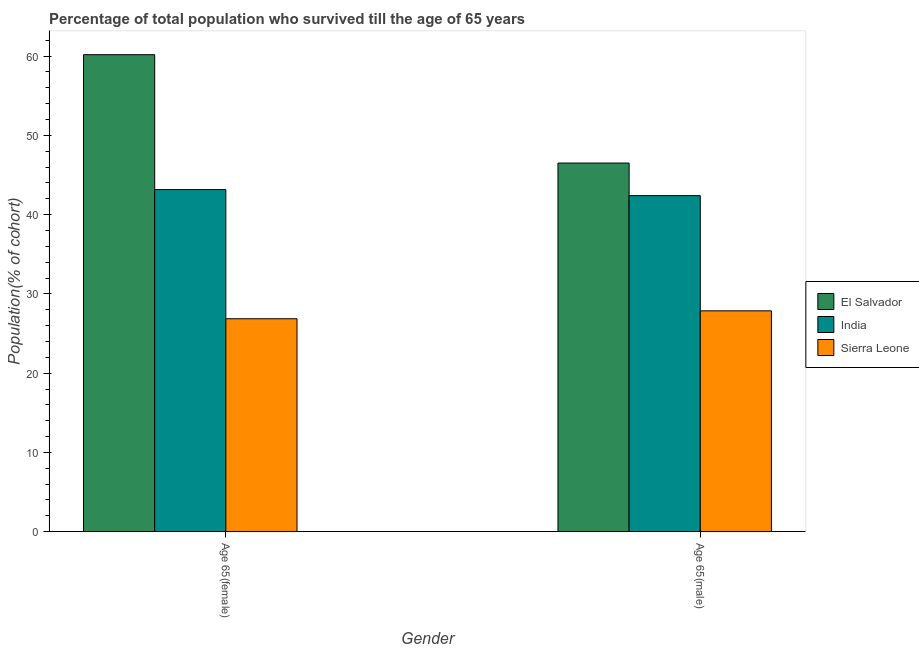Are the number of bars per tick equal to the number of legend labels?
Keep it short and to the point. Yes. How many bars are there on the 2nd tick from the right?
Keep it short and to the point. 3. What is the label of the 1st group of bars from the left?
Ensure brevity in your answer.  Age 65(female). What is the percentage of male population who survived till age of 65 in El Salvador?
Give a very brief answer. 46.5. Across all countries, what is the maximum percentage of female population who survived till age of 65?
Offer a very short reply. 60.17. Across all countries, what is the minimum percentage of male population who survived till age of 65?
Keep it short and to the point. 27.86. In which country was the percentage of male population who survived till age of 65 maximum?
Your response must be concise. El Salvador. In which country was the percentage of female population who survived till age of 65 minimum?
Your answer should be very brief. Sierra Leone. What is the total percentage of female population who survived till age of 65 in the graph?
Offer a very short reply. 130.2. What is the difference between the percentage of female population who survived till age of 65 in India and that in Sierra Leone?
Make the answer very short. 16.29. What is the difference between the percentage of female population who survived till age of 65 in India and the percentage of male population who survived till age of 65 in Sierra Leone?
Offer a very short reply. 15.3. What is the average percentage of female population who survived till age of 65 per country?
Offer a terse response. 43.4. What is the difference between the percentage of female population who survived till age of 65 and percentage of male population who survived till age of 65 in Sierra Leone?
Give a very brief answer. -1. What is the ratio of the percentage of female population who survived till age of 65 in India to that in Sierra Leone?
Offer a very short reply. 1.61. In how many countries, is the percentage of female population who survived till age of 65 greater than the average percentage of female population who survived till age of 65 taken over all countries?
Your answer should be compact. 1. What does the 2nd bar from the left in Age 65(female) represents?
Your answer should be very brief. India. What does the 1st bar from the right in Age 65(male) represents?
Your answer should be very brief. Sierra Leone. How many bars are there?
Your answer should be compact. 6. What is the difference between two consecutive major ticks on the Y-axis?
Ensure brevity in your answer.  10. Does the graph contain any zero values?
Keep it short and to the point. No. Does the graph contain grids?
Ensure brevity in your answer.  No. What is the title of the graph?
Offer a very short reply. Percentage of total population who survived till the age of 65 years. Does "Sudan" appear as one of the legend labels in the graph?
Your answer should be very brief. No. What is the label or title of the X-axis?
Provide a succinct answer. Gender. What is the label or title of the Y-axis?
Offer a very short reply. Population(% of cohort). What is the Population(% of cohort) of El Salvador in Age 65(female)?
Your answer should be compact. 60.17. What is the Population(% of cohort) of India in Age 65(female)?
Provide a short and direct response. 43.16. What is the Population(% of cohort) in Sierra Leone in Age 65(female)?
Keep it short and to the point. 26.86. What is the Population(% of cohort) of El Salvador in Age 65(male)?
Provide a short and direct response. 46.5. What is the Population(% of cohort) in India in Age 65(male)?
Ensure brevity in your answer.  42.39. What is the Population(% of cohort) of Sierra Leone in Age 65(male)?
Give a very brief answer. 27.86. Across all Gender, what is the maximum Population(% of cohort) of El Salvador?
Your response must be concise. 60.17. Across all Gender, what is the maximum Population(% of cohort) of India?
Your response must be concise. 43.16. Across all Gender, what is the maximum Population(% of cohort) of Sierra Leone?
Offer a terse response. 27.86. Across all Gender, what is the minimum Population(% of cohort) in El Salvador?
Make the answer very short. 46.5. Across all Gender, what is the minimum Population(% of cohort) of India?
Provide a succinct answer. 42.39. Across all Gender, what is the minimum Population(% of cohort) in Sierra Leone?
Offer a terse response. 26.86. What is the total Population(% of cohort) in El Salvador in the graph?
Give a very brief answer. 106.68. What is the total Population(% of cohort) of India in the graph?
Provide a short and direct response. 85.55. What is the total Population(% of cohort) in Sierra Leone in the graph?
Ensure brevity in your answer.  54.73. What is the difference between the Population(% of cohort) of El Salvador in Age 65(female) and that in Age 65(male)?
Give a very brief answer. 13.67. What is the difference between the Population(% of cohort) of India in Age 65(female) and that in Age 65(male)?
Your answer should be compact. 0.77. What is the difference between the Population(% of cohort) in Sierra Leone in Age 65(female) and that in Age 65(male)?
Your answer should be compact. -1. What is the difference between the Population(% of cohort) of El Salvador in Age 65(female) and the Population(% of cohort) of India in Age 65(male)?
Ensure brevity in your answer.  17.78. What is the difference between the Population(% of cohort) in El Salvador in Age 65(female) and the Population(% of cohort) in Sierra Leone in Age 65(male)?
Make the answer very short. 32.31. What is the difference between the Population(% of cohort) of India in Age 65(female) and the Population(% of cohort) of Sierra Leone in Age 65(male)?
Provide a succinct answer. 15.3. What is the average Population(% of cohort) of El Salvador per Gender?
Provide a succinct answer. 53.34. What is the average Population(% of cohort) in India per Gender?
Offer a terse response. 42.78. What is the average Population(% of cohort) in Sierra Leone per Gender?
Provide a short and direct response. 27.36. What is the difference between the Population(% of cohort) in El Salvador and Population(% of cohort) in India in Age 65(female)?
Offer a very short reply. 17.02. What is the difference between the Population(% of cohort) in El Salvador and Population(% of cohort) in Sierra Leone in Age 65(female)?
Give a very brief answer. 33.31. What is the difference between the Population(% of cohort) of India and Population(% of cohort) of Sierra Leone in Age 65(female)?
Make the answer very short. 16.29. What is the difference between the Population(% of cohort) of El Salvador and Population(% of cohort) of India in Age 65(male)?
Offer a terse response. 4.11. What is the difference between the Population(% of cohort) of El Salvador and Population(% of cohort) of Sierra Leone in Age 65(male)?
Your answer should be compact. 18.64. What is the difference between the Population(% of cohort) in India and Population(% of cohort) in Sierra Leone in Age 65(male)?
Offer a very short reply. 14.53. What is the ratio of the Population(% of cohort) in El Salvador in Age 65(female) to that in Age 65(male)?
Give a very brief answer. 1.29. What is the ratio of the Population(% of cohort) in India in Age 65(female) to that in Age 65(male)?
Give a very brief answer. 1.02. What is the difference between the highest and the second highest Population(% of cohort) of El Salvador?
Offer a terse response. 13.67. What is the difference between the highest and the second highest Population(% of cohort) of India?
Provide a short and direct response. 0.77. What is the difference between the highest and the second highest Population(% of cohort) of Sierra Leone?
Make the answer very short. 1. What is the difference between the highest and the lowest Population(% of cohort) of El Salvador?
Your response must be concise. 13.67. What is the difference between the highest and the lowest Population(% of cohort) in India?
Keep it short and to the point. 0.77. 